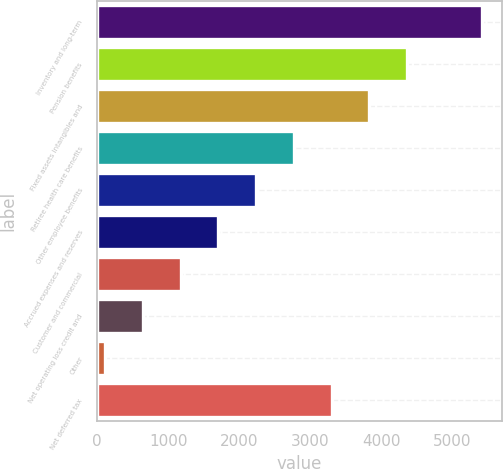Convert chart. <chart><loc_0><loc_0><loc_500><loc_500><bar_chart><fcel>Inventory and long-term<fcel>Pension benefits<fcel>Fixed assets intangibles and<fcel>Retiree health care benefits<fcel>Other employee benefits<fcel>Accrued expenses and reserves<fcel>Customer and commercial<fcel>Net operating loss credit and<fcel>Other<fcel>Net deferred tax<nl><fcel>5422<fcel>4360.6<fcel>3829.9<fcel>2768.5<fcel>2237.8<fcel>1707.1<fcel>1176.4<fcel>645.7<fcel>115<fcel>3299.2<nl></chart> 